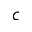Convert formula to latex. <formula><loc_0><loc_0><loc_500><loc_500>c</formula> 